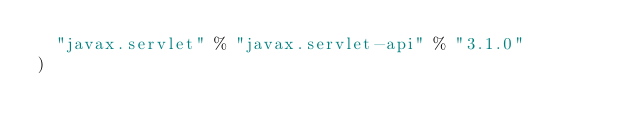<code> <loc_0><loc_0><loc_500><loc_500><_Scala_>  "javax.servlet" % "javax.servlet-api" % "3.1.0"
)</code> 